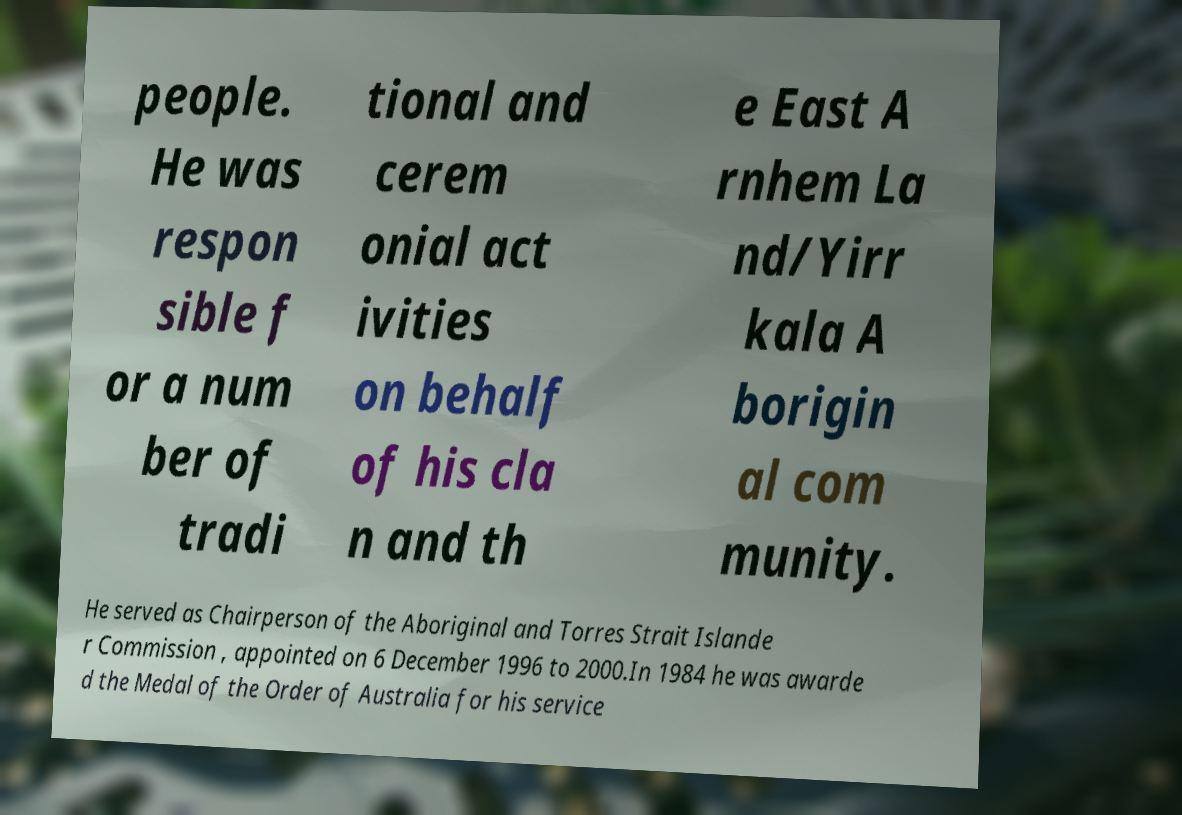Please read and relay the text visible in this image. What does it say? people. He was respon sible f or a num ber of tradi tional and cerem onial act ivities on behalf of his cla n and th e East A rnhem La nd/Yirr kala A borigin al com munity. He served as Chairperson of the Aboriginal and Torres Strait Islande r Commission , appointed on 6 December 1996 to 2000.In 1984 he was awarde d the Medal of the Order of Australia for his service 